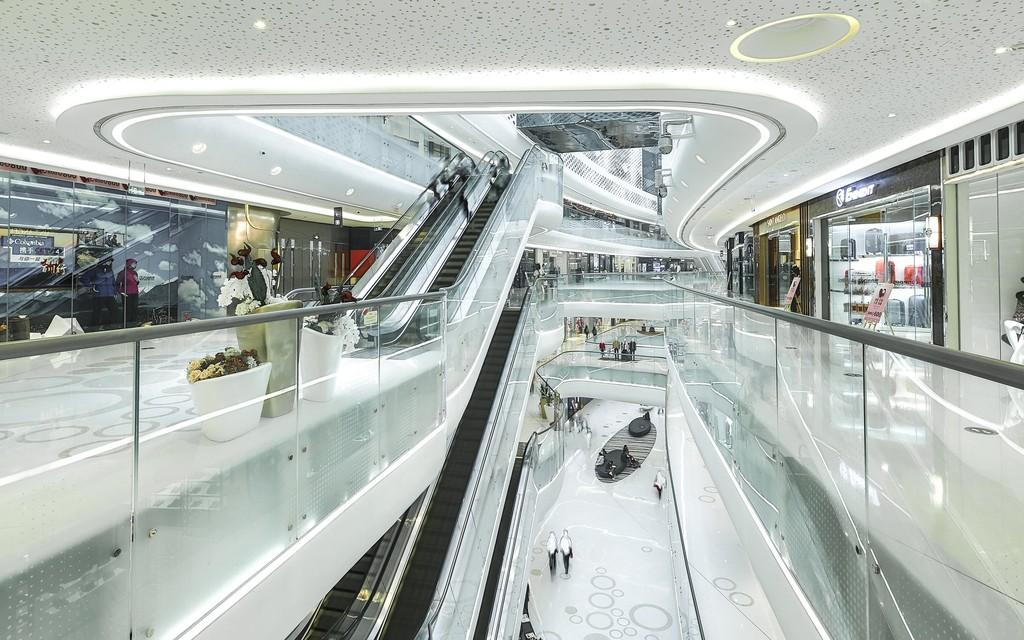What type of location is depicted in the image? The image shows an inside view of a building. What architectural feature can be seen in the image? There are railings in the image. What mode of transportation is available in the building? Escalators are present in the image. What type of decorative elements are present in the image? There are pots with plants on the floor. Are there any people visible in the image? Yes, some people are visible in the image. What type of establishment is present in the building? There are shops in the image. What type of signage is present in the image? Boards are present in the image. What part of the building is visible in the image? The image includes a ceiling. What type of lighting is present in the image? Lights are visible in the image. What other objects can be seen in the image? There are various objects in the image. How many tomatoes are on the escalator in the image? There are no tomatoes present in the image, and therefore no tomatoes can be found on the escalator. Can you hear someone sneezing in the image? The image is a still photograph and does not include any auditory information, so it is impossible to hear someone sneezing in the image. Is there a toad visible in the image? There is no toad present in the image. 